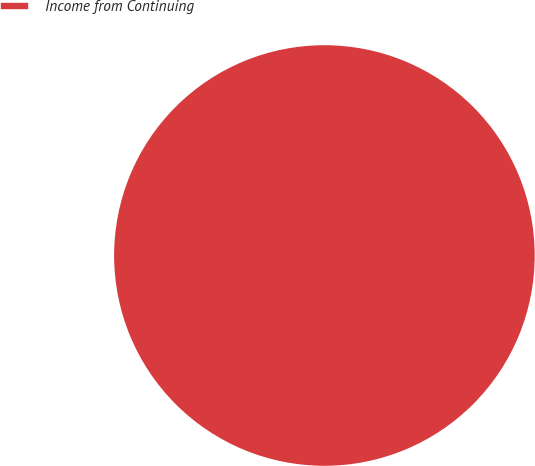Convert chart to OTSL. <chart><loc_0><loc_0><loc_500><loc_500><pie_chart><fcel>Income from Continuing<nl><fcel>100.0%<nl></chart> 